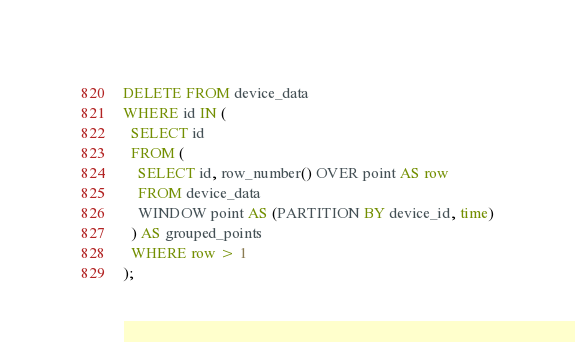Convert code to text. <code><loc_0><loc_0><loc_500><loc_500><_SQL_>DELETE FROM device_data
WHERE id IN (
  SELECT id
  FROM (
    SELECT id, row_number() OVER point AS row
    FROM device_data
    WINDOW point AS (PARTITION BY device_id, time)
  ) AS grouped_points
  WHERE row > 1
);
</code> 